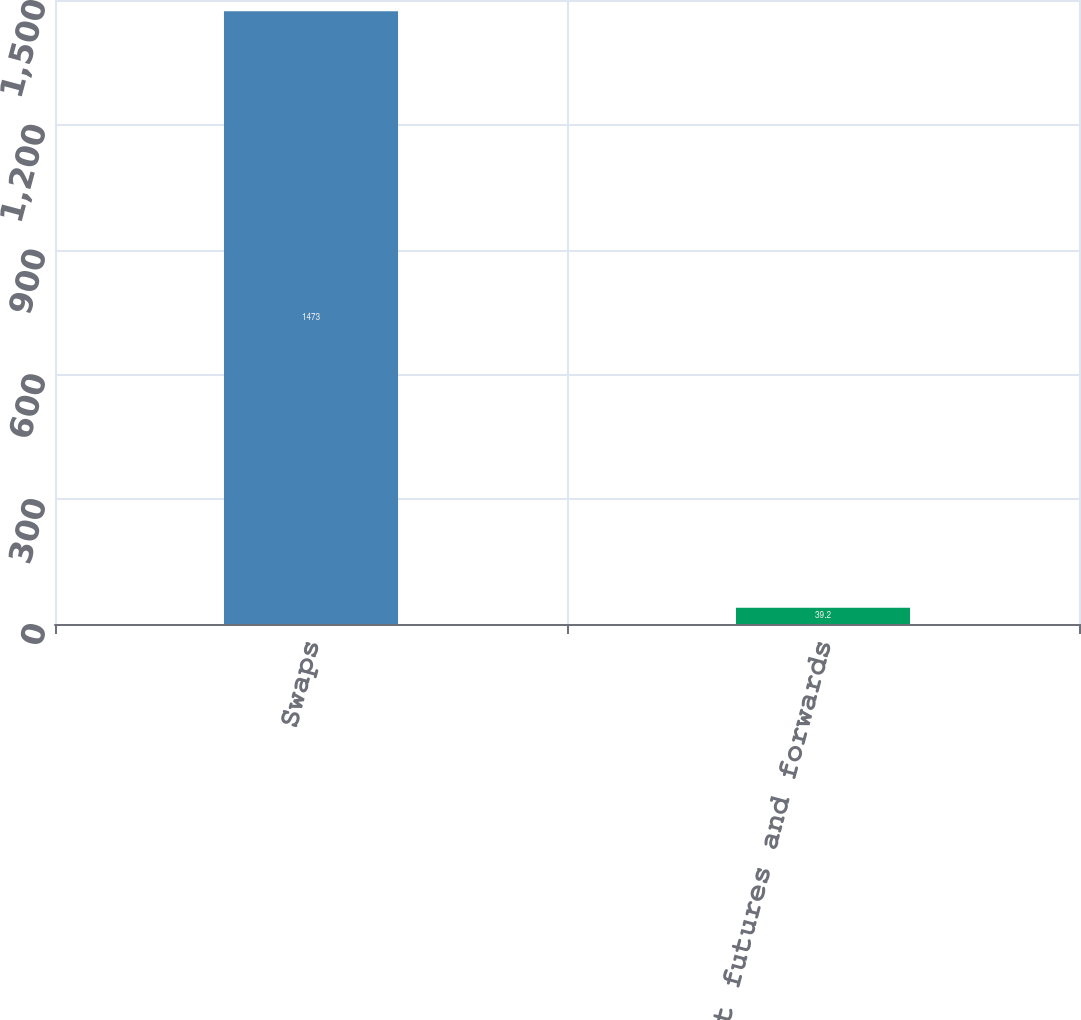Convert chart to OTSL. <chart><loc_0><loc_0><loc_500><loc_500><bar_chart><fcel>Swaps<fcel>Spot futures and forwards<nl><fcel>1473<fcel>39.2<nl></chart> 